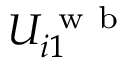Convert formula to latex. <formula><loc_0><loc_0><loc_500><loc_500>U _ { i 1 } ^ { w b }</formula> 